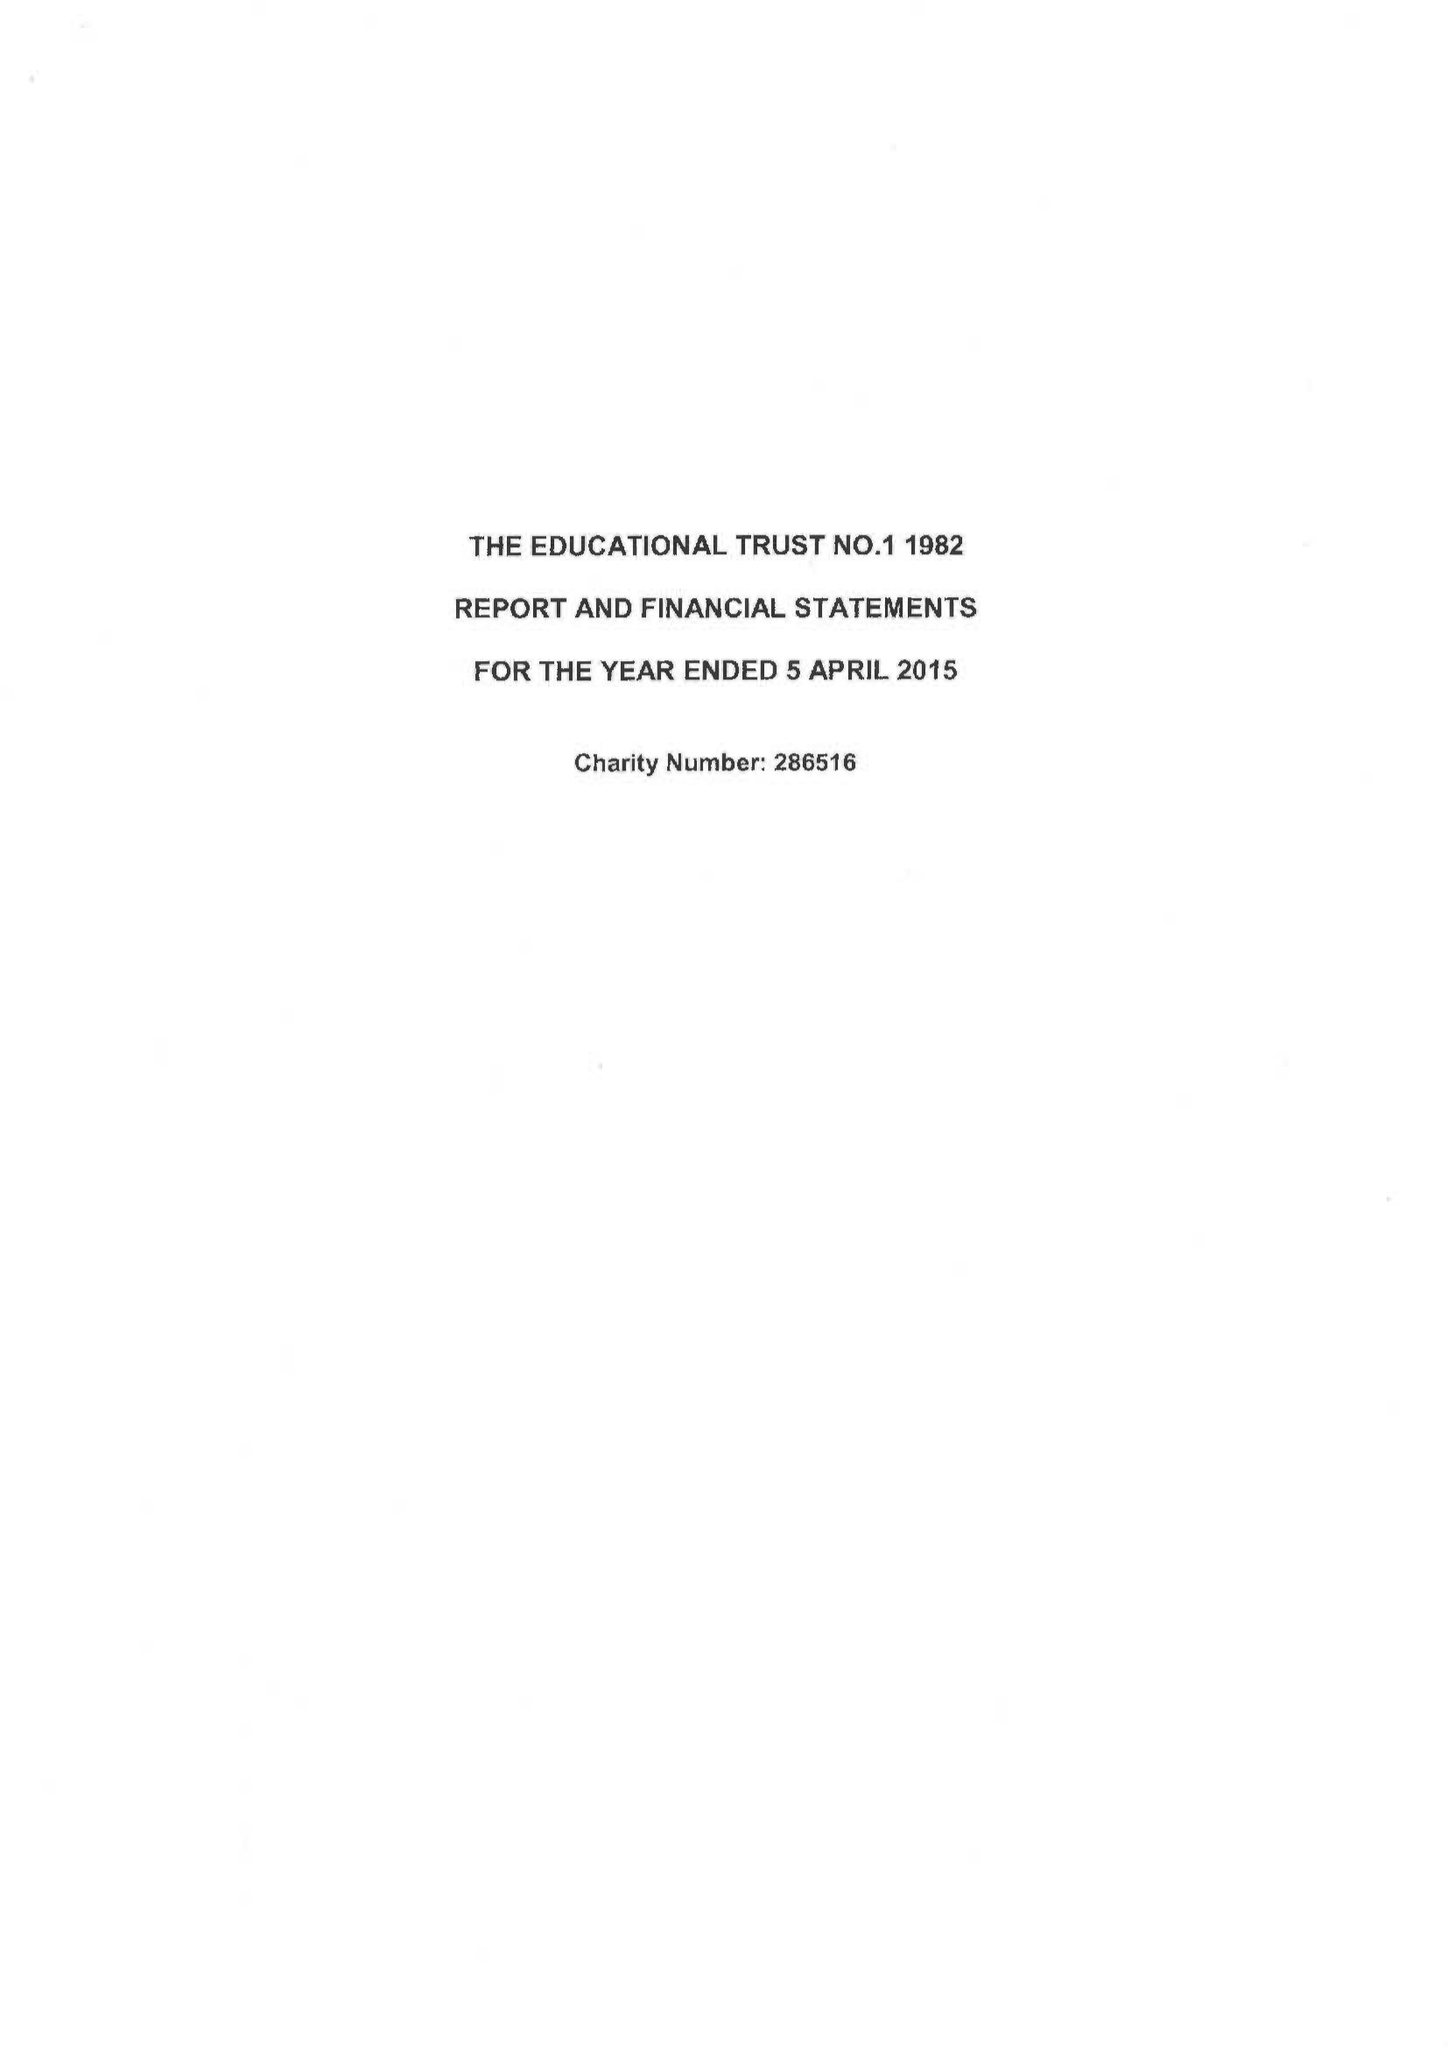What is the value for the spending_annually_in_british_pounds?
Answer the question using a single word or phrase. 248596.00 